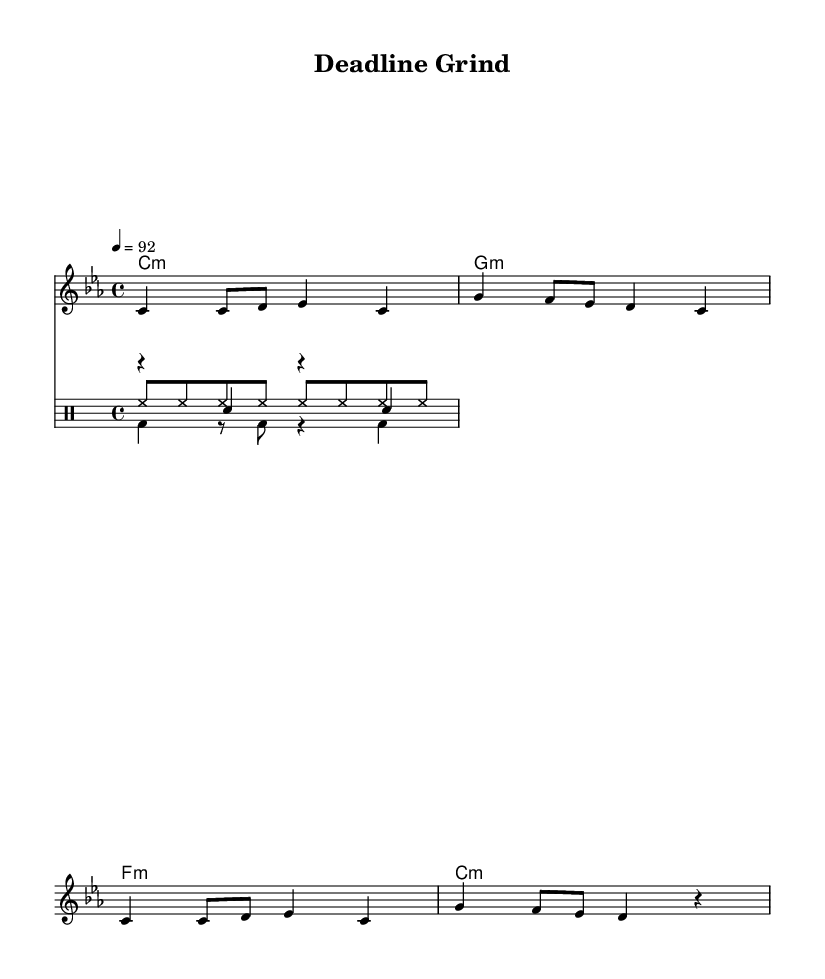What is the key signature of this music? The key signature is C minor, indicated by three flat notes on the staff (B♭, E♭, A♭).
Answer: C minor What is the time signature of this music? The time signature is indicated as 4/4, meaning there are four beats in each measure, and a quarter note gets one beat.
Answer: 4/4 What is the tempo marking of the piece? The tempo marking shows "4 = 92", which indicates that there are 92 quarter note beats per minute.
Answer: 92 How many measures are in the melody section? Counting the distinct segments in the melody, there are four measures (the music has a repeated structure).
Answer: 4 Which type of drum is primarily used for the backbeat in this piece? The snare drum is commonly used for backbeats in Hip Hop; in the sheet music, the snare hits are indicated and emphasize the second and fourth beats in the measures.
Answer: Snare What thematic element do the lyrics focus on? The lyrics focus on the grind and hustle involved in sports journalism, discussing deadlines, competition, and survival in the field.
Answer: Grind and hustle 